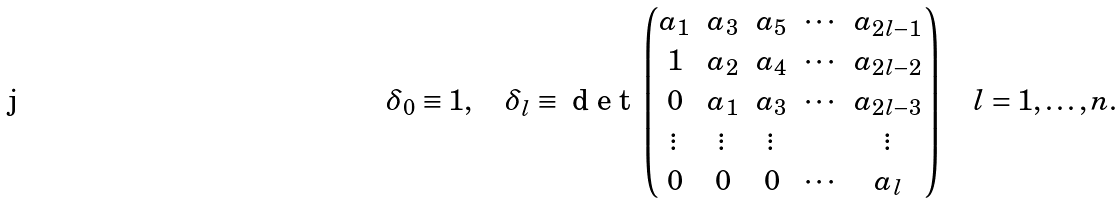Convert formula to latex. <formula><loc_0><loc_0><loc_500><loc_500>\delta _ { 0 } \equiv 1 , \quad \delta _ { l } \equiv \emph { d e t } \begin{pmatrix} a _ { 1 } & a _ { 3 } & a _ { 5 } & \cdots & a _ { 2 l - 1 } \\ 1 & a _ { 2 } & a _ { 4 } & \cdots & a _ { 2 l - 2 } \\ 0 & a _ { 1 } & a _ { 3 } & \cdots & a _ { 2 l - 3 } \\ \vdots & \vdots & \vdots & \quad & \vdots \\ 0 & 0 & 0 & \cdots & a _ { l } \end{pmatrix} \quad l = 1 , \dots , n .</formula> 